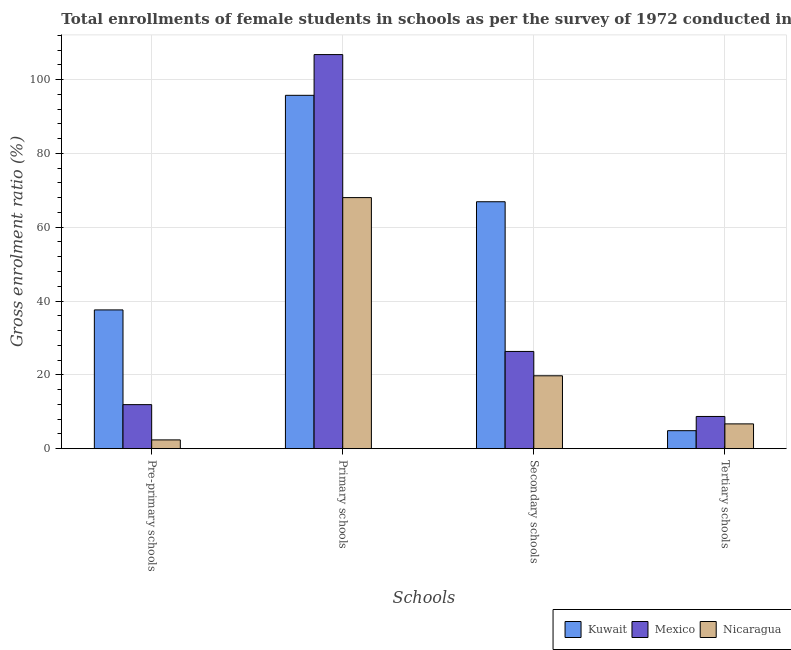How many different coloured bars are there?
Make the answer very short. 3. How many groups of bars are there?
Provide a short and direct response. 4. Are the number of bars on each tick of the X-axis equal?
Ensure brevity in your answer.  Yes. How many bars are there on the 2nd tick from the right?
Give a very brief answer. 3. What is the label of the 2nd group of bars from the left?
Ensure brevity in your answer.  Primary schools. What is the gross enrolment ratio(female) in pre-primary schools in Kuwait?
Your answer should be compact. 37.59. Across all countries, what is the maximum gross enrolment ratio(female) in tertiary schools?
Offer a terse response. 8.73. Across all countries, what is the minimum gross enrolment ratio(female) in secondary schools?
Your answer should be compact. 19.75. In which country was the gross enrolment ratio(female) in secondary schools minimum?
Your answer should be compact. Nicaragua. What is the total gross enrolment ratio(female) in pre-primary schools in the graph?
Make the answer very short. 51.91. What is the difference between the gross enrolment ratio(female) in primary schools in Kuwait and that in Nicaragua?
Ensure brevity in your answer.  27.71. What is the difference between the gross enrolment ratio(female) in pre-primary schools in Kuwait and the gross enrolment ratio(female) in secondary schools in Mexico?
Ensure brevity in your answer.  11.25. What is the average gross enrolment ratio(female) in tertiary schools per country?
Offer a terse response. 6.77. What is the difference between the gross enrolment ratio(female) in tertiary schools and gross enrolment ratio(female) in pre-primary schools in Kuwait?
Offer a very short reply. -32.72. In how many countries, is the gross enrolment ratio(female) in pre-primary schools greater than 84 %?
Your answer should be compact. 0. What is the ratio of the gross enrolment ratio(female) in tertiary schools in Mexico to that in Kuwait?
Ensure brevity in your answer.  1.79. Is the difference between the gross enrolment ratio(female) in pre-primary schools in Mexico and Kuwait greater than the difference between the gross enrolment ratio(female) in primary schools in Mexico and Kuwait?
Your response must be concise. No. What is the difference between the highest and the second highest gross enrolment ratio(female) in tertiary schools?
Your answer should be very brief. 2.01. What is the difference between the highest and the lowest gross enrolment ratio(female) in secondary schools?
Provide a short and direct response. 47.15. Is the sum of the gross enrolment ratio(female) in tertiary schools in Nicaragua and Kuwait greater than the maximum gross enrolment ratio(female) in pre-primary schools across all countries?
Offer a terse response. No. What does the 3rd bar from the left in Pre-primary schools represents?
Your response must be concise. Nicaragua. Is it the case that in every country, the sum of the gross enrolment ratio(female) in pre-primary schools and gross enrolment ratio(female) in primary schools is greater than the gross enrolment ratio(female) in secondary schools?
Provide a short and direct response. Yes. Are all the bars in the graph horizontal?
Provide a succinct answer. No. How many countries are there in the graph?
Offer a terse response. 3. Does the graph contain grids?
Offer a terse response. Yes. How are the legend labels stacked?
Keep it short and to the point. Horizontal. What is the title of the graph?
Your response must be concise. Total enrollments of female students in schools as per the survey of 1972 conducted in different countries. Does "South Africa" appear as one of the legend labels in the graph?
Your response must be concise. No. What is the label or title of the X-axis?
Your response must be concise. Schools. What is the Gross enrolment ratio (%) of Kuwait in Pre-primary schools?
Your answer should be compact. 37.59. What is the Gross enrolment ratio (%) in Mexico in Pre-primary schools?
Provide a short and direct response. 11.93. What is the Gross enrolment ratio (%) in Nicaragua in Pre-primary schools?
Keep it short and to the point. 2.38. What is the Gross enrolment ratio (%) in Kuwait in Primary schools?
Keep it short and to the point. 95.73. What is the Gross enrolment ratio (%) in Mexico in Primary schools?
Your response must be concise. 106.77. What is the Gross enrolment ratio (%) of Nicaragua in Primary schools?
Keep it short and to the point. 68.02. What is the Gross enrolment ratio (%) of Kuwait in Secondary schools?
Give a very brief answer. 66.9. What is the Gross enrolment ratio (%) of Mexico in Secondary schools?
Keep it short and to the point. 26.34. What is the Gross enrolment ratio (%) in Nicaragua in Secondary schools?
Make the answer very short. 19.75. What is the Gross enrolment ratio (%) in Kuwait in Tertiary schools?
Your answer should be very brief. 4.88. What is the Gross enrolment ratio (%) in Mexico in Tertiary schools?
Offer a terse response. 8.73. What is the Gross enrolment ratio (%) in Nicaragua in Tertiary schools?
Offer a terse response. 6.72. Across all Schools, what is the maximum Gross enrolment ratio (%) in Kuwait?
Offer a very short reply. 95.73. Across all Schools, what is the maximum Gross enrolment ratio (%) in Mexico?
Make the answer very short. 106.77. Across all Schools, what is the maximum Gross enrolment ratio (%) in Nicaragua?
Ensure brevity in your answer.  68.02. Across all Schools, what is the minimum Gross enrolment ratio (%) in Kuwait?
Offer a terse response. 4.88. Across all Schools, what is the minimum Gross enrolment ratio (%) of Mexico?
Provide a succinct answer. 8.73. Across all Schools, what is the minimum Gross enrolment ratio (%) in Nicaragua?
Your answer should be compact. 2.38. What is the total Gross enrolment ratio (%) of Kuwait in the graph?
Ensure brevity in your answer.  205.1. What is the total Gross enrolment ratio (%) of Mexico in the graph?
Your answer should be very brief. 153.77. What is the total Gross enrolment ratio (%) in Nicaragua in the graph?
Offer a terse response. 96.87. What is the difference between the Gross enrolment ratio (%) in Kuwait in Pre-primary schools and that in Primary schools?
Your response must be concise. -58.14. What is the difference between the Gross enrolment ratio (%) of Mexico in Pre-primary schools and that in Primary schools?
Provide a succinct answer. -94.84. What is the difference between the Gross enrolment ratio (%) in Nicaragua in Pre-primary schools and that in Primary schools?
Ensure brevity in your answer.  -65.64. What is the difference between the Gross enrolment ratio (%) of Kuwait in Pre-primary schools and that in Secondary schools?
Provide a succinct answer. -29.31. What is the difference between the Gross enrolment ratio (%) in Mexico in Pre-primary schools and that in Secondary schools?
Provide a short and direct response. -14.41. What is the difference between the Gross enrolment ratio (%) of Nicaragua in Pre-primary schools and that in Secondary schools?
Provide a short and direct response. -17.37. What is the difference between the Gross enrolment ratio (%) in Kuwait in Pre-primary schools and that in Tertiary schools?
Your answer should be compact. 32.72. What is the difference between the Gross enrolment ratio (%) in Mexico in Pre-primary schools and that in Tertiary schools?
Ensure brevity in your answer.  3.2. What is the difference between the Gross enrolment ratio (%) in Nicaragua in Pre-primary schools and that in Tertiary schools?
Keep it short and to the point. -4.34. What is the difference between the Gross enrolment ratio (%) of Kuwait in Primary schools and that in Secondary schools?
Your answer should be compact. 28.83. What is the difference between the Gross enrolment ratio (%) of Mexico in Primary schools and that in Secondary schools?
Make the answer very short. 80.43. What is the difference between the Gross enrolment ratio (%) in Nicaragua in Primary schools and that in Secondary schools?
Offer a terse response. 48.28. What is the difference between the Gross enrolment ratio (%) in Kuwait in Primary schools and that in Tertiary schools?
Provide a succinct answer. 90.85. What is the difference between the Gross enrolment ratio (%) in Mexico in Primary schools and that in Tertiary schools?
Offer a terse response. 98.04. What is the difference between the Gross enrolment ratio (%) of Nicaragua in Primary schools and that in Tertiary schools?
Ensure brevity in your answer.  61.31. What is the difference between the Gross enrolment ratio (%) in Kuwait in Secondary schools and that in Tertiary schools?
Your answer should be very brief. 62.02. What is the difference between the Gross enrolment ratio (%) in Mexico in Secondary schools and that in Tertiary schools?
Provide a succinct answer. 17.61. What is the difference between the Gross enrolment ratio (%) in Nicaragua in Secondary schools and that in Tertiary schools?
Your response must be concise. 13.03. What is the difference between the Gross enrolment ratio (%) in Kuwait in Pre-primary schools and the Gross enrolment ratio (%) in Mexico in Primary schools?
Offer a very short reply. -69.17. What is the difference between the Gross enrolment ratio (%) in Kuwait in Pre-primary schools and the Gross enrolment ratio (%) in Nicaragua in Primary schools?
Provide a short and direct response. -30.43. What is the difference between the Gross enrolment ratio (%) in Mexico in Pre-primary schools and the Gross enrolment ratio (%) in Nicaragua in Primary schools?
Your answer should be very brief. -56.09. What is the difference between the Gross enrolment ratio (%) of Kuwait in Pre-primary schools and the Gross enrolment ratio (%) of Mexico in Secondary schools?
Make the answer very short. 11.25. What is the difference between the Gross enrolment ratio (%) in Kuwait in Pre-primary schools and the Gross enrolment ratio (%) in Nicaragua in Secondary schools?
Your response must be concise. 17.85. What is the difference between the Gross enrolment ratio (%) in Mexico in Pre-primary schools and the Gross enrolment ratio (%) in Nicaragua in Secondary schools?
Give a very brief answer. -7.82. What is the difference between the Gross enrolment ratio (%) in Kuwait in Pre-primary schools and the Gross enrolment ratio (%) in Mexico in Tertiary schools?
Keep it short and to the point. 28.87. What is the difference between the Gross enrolment ratio (%) in Kuwait in Pre-primary schools and the Gross enrolment ratio (%) in Nicaragua in Tertiary schools?
Offer a very short reply. 30.88. What is the difference between the Gross enrolment ratio (%) in Mexico in Pre-primary schools and the Gross enrolment ratio (%) in Nicaragua in Tertiary schools?
Offer a very short reply. 5.22. What is the difference between the Gross enrolment ratio (%) in Kuwait in Primary schools and the Gross enrolment ratio (%) in Mexico in Secondary schools?
Your answer should be compact. 69.39. What is the difference between the Gross enrolment ratio (%) in Kuwait in Primary schools and the Gross enrolment ratio (%) in Nicaragua in Secondary schools?
Ensure brevity in your answer.  75.98. What is the difference between the Gross enrolment ratio (%) in Mexico in Primary schools and the Gross enrolment ratio (%) in Nicaragua in Secondary schools?
Make the answer very short. 87.02. What is the difference between the Gross enrolment ratio (%) of Kuwait in Primary schools and the Gross enrolment ratio (%) of Mexico in Tertiary schools?
Your answer should be very brief. 87. What is the difference between the Gross enrolment ratio (%) in Kuwait in Primary schools and the Gross enrolment ratio (%) in Nicaragua in Tertiary schools?
Offer a very short reply. 89.02. What is the difference between the Gross enrolment ratio (%) of Mexico in Primary schools and the Gross enrolment ratio (%) of Nicaragua in Tertiary schools?
Ensure brevity in your answer.  100.05. What is the difference between the Gross enrolment ratio (%) in Kuwait in Secondary schools and the Gross enrolment ratio (%) in Mexico in Tertiary schools?
Make the answer very short. 58.17. What is the difference between the Gross enrolment ratio (%) of Kuwait in Secondary schools and the Gross enrolment ratio (%) of Nicaragua in Tertiary schools?
Keep it short and to the point. 60.19. What is the difference between the Gross enrolment ratio (%) of Mexico in Secondary schools and the Gross enrolment ratio (%) of Nicaragua in Tertiary schools?
Ensure brevity in your answer.  19.63. What is the average Gross enrolment ratio (%) in Kuwait per Schools?
Ensure brevity in your answer.  51.28. What is the average Gross enrolment ratio (%) in Mexico per Schools?
Your answer should be very brief. 38.44. What is the average Gross enrolment ratio (%) in Nicaragua per Schools?
Keep it short and to the point. 24.22. What is the difference between the Gross enrolment ratio (%) of Kuwait and Gross enrolment ratio (%) of Mexico in Pre-primary schools?
Your answer should be compact. 25.66. What is the difference between the Gross enrolment ratio (%) in Kuwait and Gross enrolment ratio (%) in Nicaragua in Pre-primary schools?
Your response must be concise. 35.21. What is the difference between the Gross enrolment ratio (%) in Mexico and Gross enrolment ratio (%) in Nicaragua in Pre-primary schools?
Offer a very short reply. 9.55. What is the difference between the Gross enrolment ratio (%) of Kuwait and Gross enrolment ratio (%) of Mexico in Primary schools?
Make the answer very short. -11.04. What is the difference between the Gross enrolment ratio (%) in Kuwait and Gross enrolment ratio (%) in Nicaragua in Primary schools?
Your answer should be very brief. 27.71. What is the difference between the Gross enrolment ratio (%) of Mexico and Gross enrolment ratio (%) of Nicaragua in Primary schools?
Give a very brief answer. 38.75. What is the difference between the Gross enrolment ratio (%) of Kuwait and Gross enrolment ratio (%) of Mexico in Secondary schools?
Your response must be concise. 40.56. What is the difference between the Gross enrolment ratio (%) in Kuwait and Gross enrolment ratio (%) in Nicaragua in Secondary schools?
Provide a short and direct response. 47.15. What is the difference between the Gross enrolment ratio (%) in Mexico and Gross enrolment ratio (%) in Nicaragua in Secondary schools?
Keep it short and to the point. 6.59. What is the difference between the Gross enrolment ratio (%) in Kuwait and Gross enrolment ratio (%) in Mexico in Tertiary schools?
Provide a succinct answer. -3.85. What is the difference between the Gross enrolment ratio (%) in Kuwait and Gross enrolment ratio (%) in Nicaragua in Tertiary schools?
Provide a short and direct response. -1.84. What is the difference between the Gross enrolment ratio (%) of Mexico and Gross enrolment ratio (%) of Nicaragua in Tertiary schools?
Make the answer very short. 2.01. What is the ratio of the Gross enrolment ratio (%) of Kuwait in Pre-primary schools to that in Primary schools?
Give a very brief answer. 0.39. What is the ratio of the Gross enrolment ratio (%) in Mexico in Pre-primary schools to that in Primary schools?
Offer a terse response. 0.11. What is the ratio of the Gross enrolment ratio (%) in Nicaragua in Pre-primary schools to that in Primary schools?
Offer a very short reply. 0.04. What is the ratio of the Gross enrolment ratio (%) in Kuwait in Pre-primary schools to that in Secondary schools?
Give a very brief answer. 0.56. What is the ratio of the Gross enrolment ratio (%) of Mexico in Pre-primary schools to that in Secondary schools?
Provide a succinct answer. 0.45. What is the ratio of the Gross enrolment ratio (%) in Nicaragua in Pre-primary schools to that in Secondary schools?
Your response must be concise. 0.12. What is the ratio of the Gross enrolment ratio (%) in Kuwait in Pre-primary schools to that in Tertiary schools?
Keep it short and to the point. 7.71. What is the ratio of the Gross enrolment ratio (%) in Mexico in Pre-primary schools to that in Tertiary schools?
Offer a very short reply. 1.37. What is the ratio of the Gross enrolment ratio (%) in Nicaragua in Pre-primary schools to that in Tertiary schools?
Your answer should be compact. 0.35. What is the ratio of the Gross enrolment ratio (%) in Kuwait in Primary schools to that in Secondary schools?
Your answer should be compact. 1.43. What is the ratio of the Gross enrolment ratio (%) in Mexico in Primary schools to that in Secondary schools?
Your answer should be compact. 4.05. What is the ratio of the Gross enrolment ratio (%) in Nicaragua in Primary schools to that in Secondary schools?
Make the answer very short. 3.44. What is the ratio of the Gross enrolment ratio (%) of Kuwait in Primary schools to that in Tertiary schools?
Your response must be concise. 19.63. What is the ratio of the Gross enrolment ratio (%) in Mexico in Primary schools to that in Tertiary schools?
Keep it short and to the point. 12.23. What is the ratio of the Gross enrolment ratio (%) of Nicaragua in Primary schools to that in Tertiary schools?
Offer a very short reply. 10.13. What is the ratio of the Gross enrolment ratio (%) of Kuwait in Secondary schools to that in Tertiary schools?
Provide a succinct answer. 13.72. What is the ratio of the Gross enrolment ratio (%) in Mexico in Secondary schools to that in Tertiary schools?
Provide a succinct answer. 3.02. What is the ratio of the Gross enrolment ratio (%) of Nicaragua in Secondary schools to that in Tertiary schools?
Ensure brevity in your answer.  2.94. What is the difference between the highest and the second highest Gross enrolment ratio (%) in Kuwait?
Give a very brief answer. 28.83. What is the difference between the highest and the second highest Gross enrolment ratio (%) of Mexico?
Offer a very short reply. 80.43. What is the difference between the highest and the second highest Gross enrolment ratio (%) of Nicaragua?
Offer a very short reply. 48.28. What is the difference between the highest and the lowest Gross enrolment ratio (%) in Kuwait?
Ensure brevity in your answer.  90.85. What is the difference between the highest and the lowest Gross enrolment ratio (%) of Mexico?
Keep it short and to the point. 98.04. What is the difference between the highest and the lowest Gross enrolment ratio (%) in Nicaragua?
Your response must be concise. 65.64. 